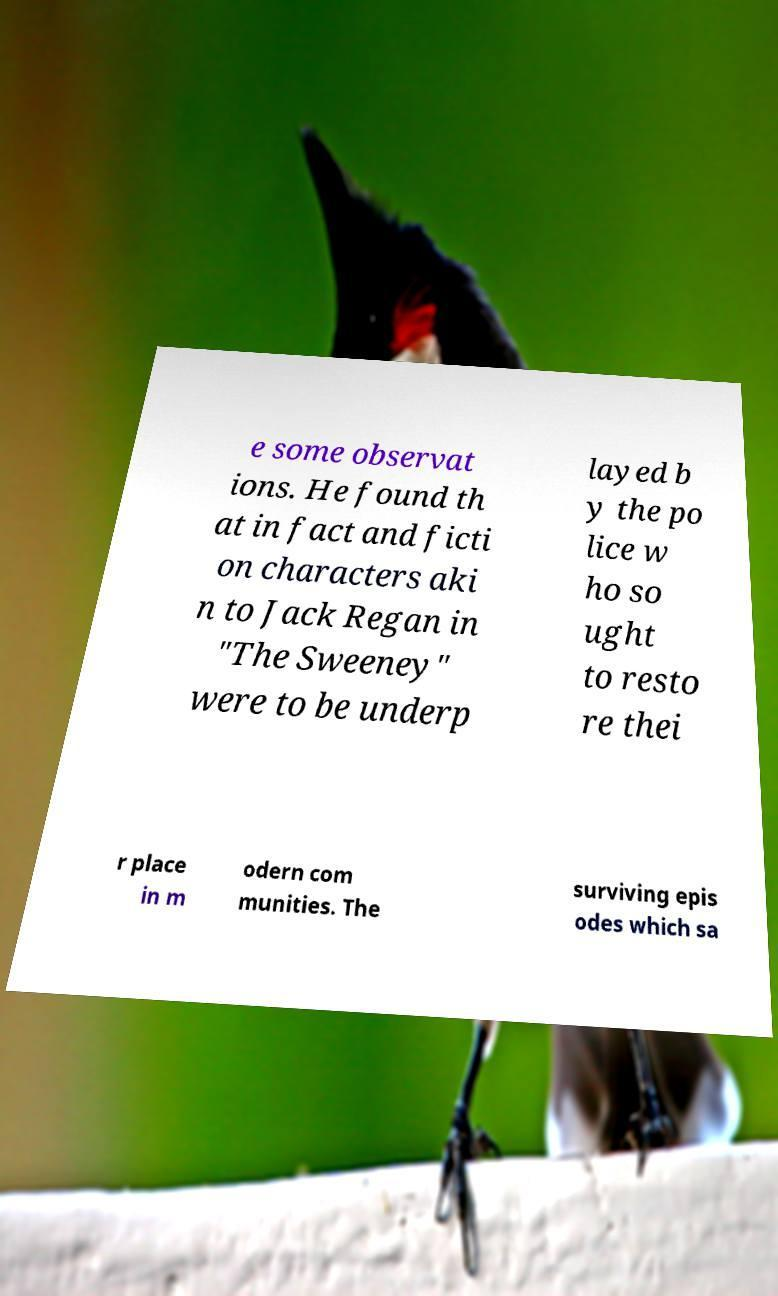Could you extract and type out the text from this image? e some observat ions. He found th at in fact and ficti on characters aki n to Jack Regan in "The Sweeney" were to be underp layed b y the po lice w ho so ught to resto re thei r place in m odern com munities. The surviving epis odes which sa 